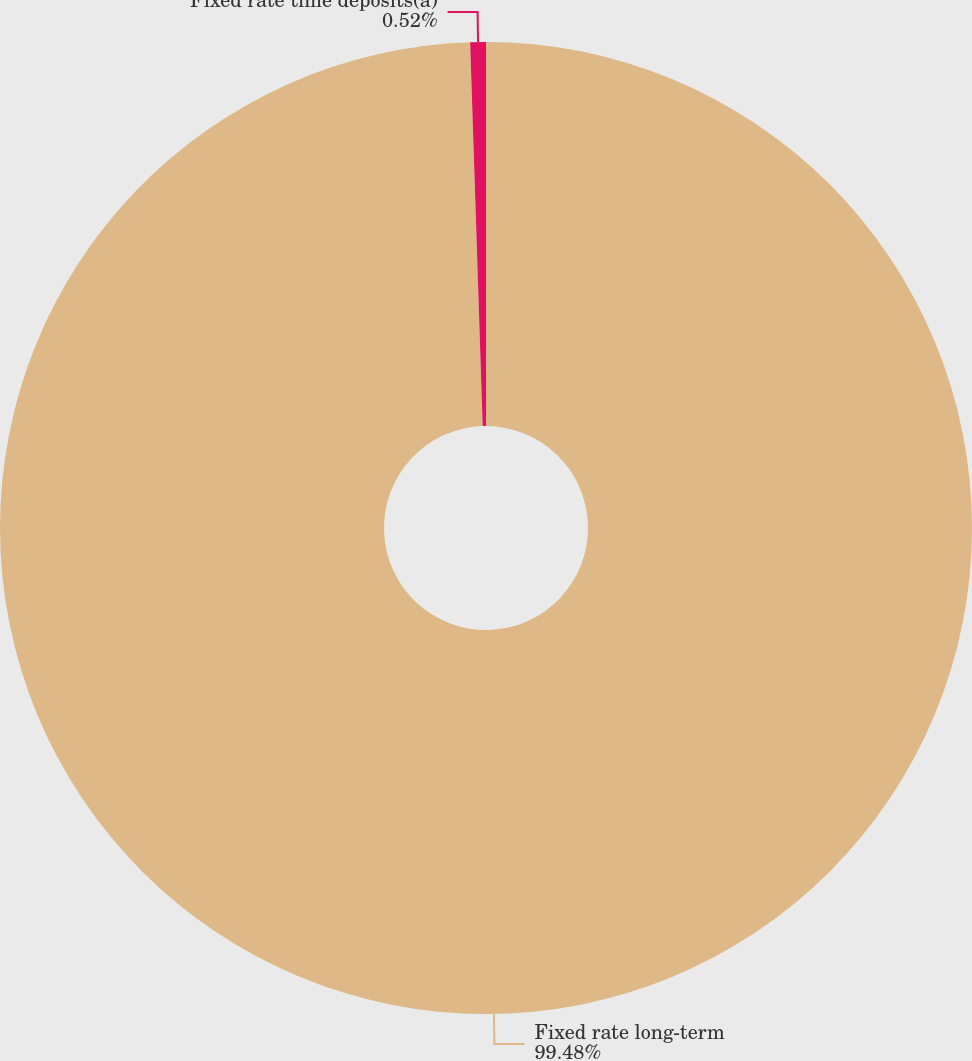<chart> <loc_0><loc_0><loc_500><loc_500><pie_chart><fcel>Fixed rate long-term<fcel>Fixed rate time deposits(a)<nl><fcel>99.48%<fcel>0.52%<nl></chart> 